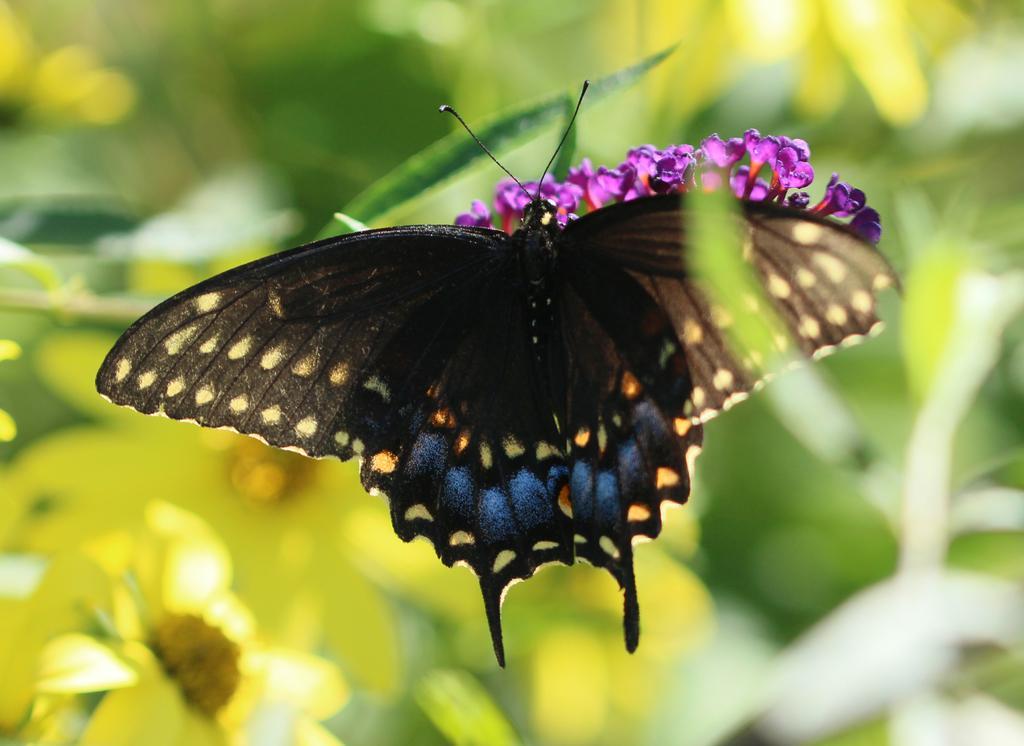Could you give a brief overview of what you see in this image? In this image we can see a butterfly and also the flowers. The background is blurred with the flowers and also leaves. 